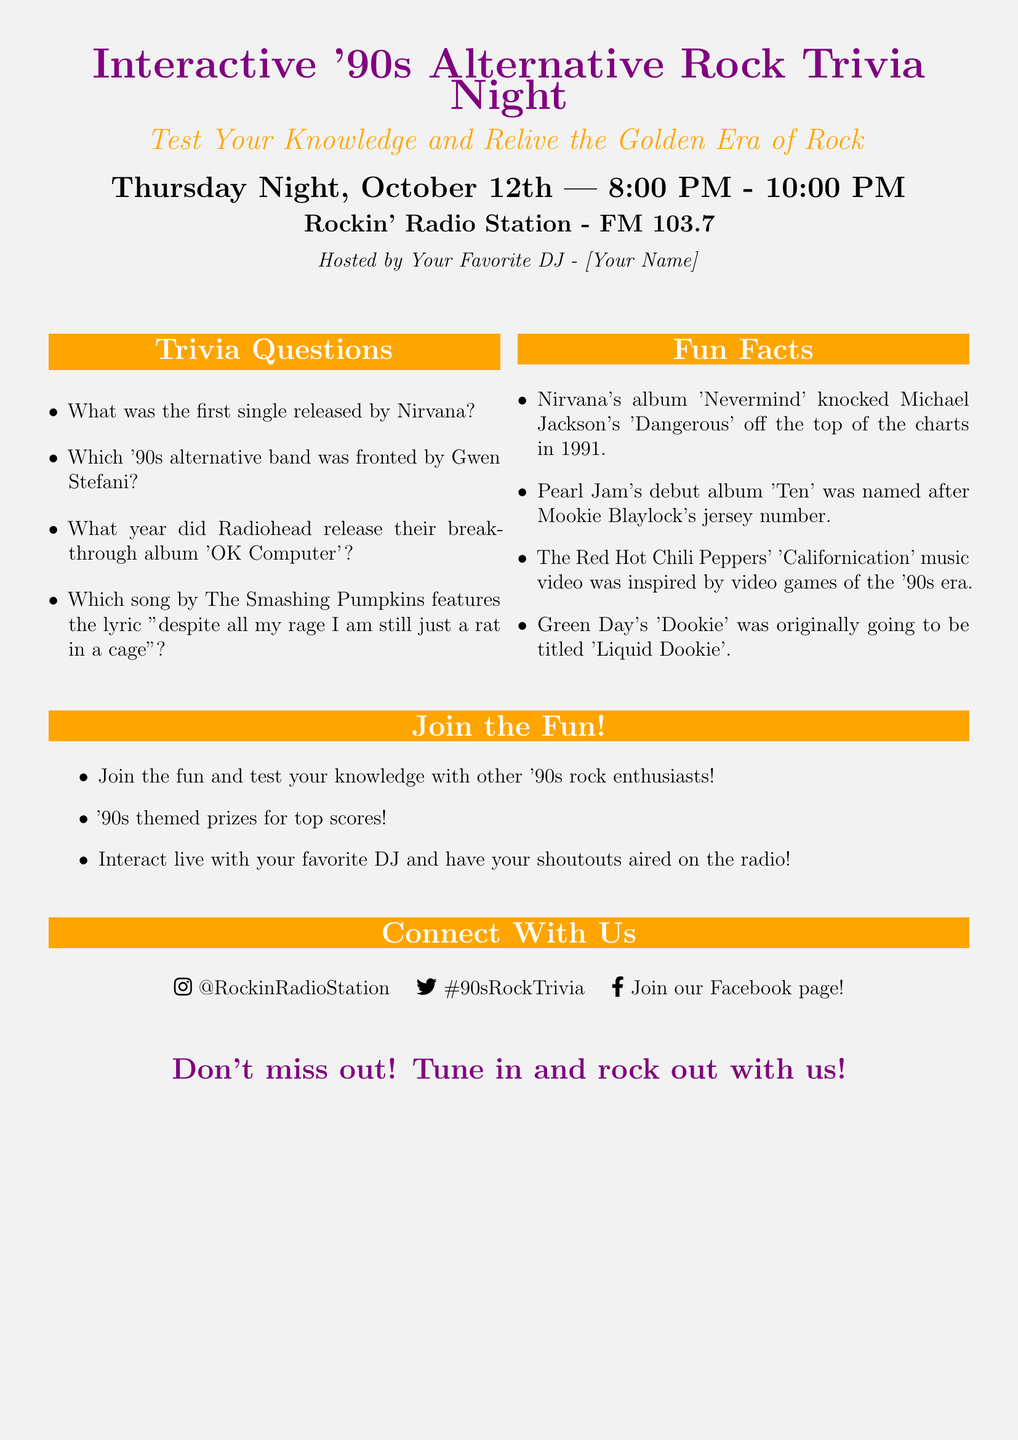What is the event title? The event title is prominently displayed at the top of the poster.
Answer: Interactive '90s Alternative Rock Trivia Night Which radio station is hosting the event? The hosting station is mentioned right before the DJ's name.
Answer: Rockin' Radio Station - FM 103.7 Who is hosting the trivia night? The host's name is referred to as [Your Name] in the poster.
Answer: [Your Name] What is the first trivia question listed? The first trivia question is positioned in the trivia section of the document.
Answer: What was the first single released by Nirvana? What fun fact is about Pearl Jam's debut album? This fun fact is listed under the Fun Facts section of the document.
Answer: Pearl Jam's debut album 'Ten' was named after Mookie Blaylock's jersey number What theme is mentioned for the top scores? The information regarding prizes is presented under the Join the Fun! section.
Answer: '90s themed prizes for top scores! What social media platform is mentioned first? The order of social media platforms is identified under the Connect With Us section.
Answer: Instagram What year did Radiohead release 'OK Computer'? This question can be inferred to be part of the trivia questions list.
Answer: Not provided in the document, as it's a trivia question to answer 